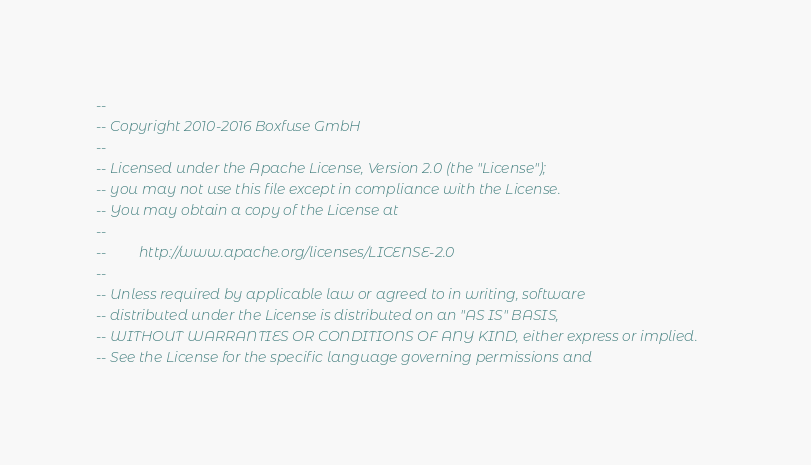<code> <loc_0><loc_0><loc_500><loc_500><_SQL_>--
-- Copyright 2010-2016 Boxfuse GmbH
--
-- Licensed under the Apache License, Version 2.0 (the "License");
-- you may not use this file except in compliance with the License.
-- You may obtain a copy of the License at
--
--         http://www.apache.org/licenses/LICENSE-2.0
--
-- Unless required by applicable law or agreed to in writing, software
-- distributed under the License is distributed on an "AS IS" BASIS,
-- WITHOUT WARRANTIES OR CONDITIONS OF ANY KIND, either express or implied.
-- See the License for the specific language governing permissions and</code> 